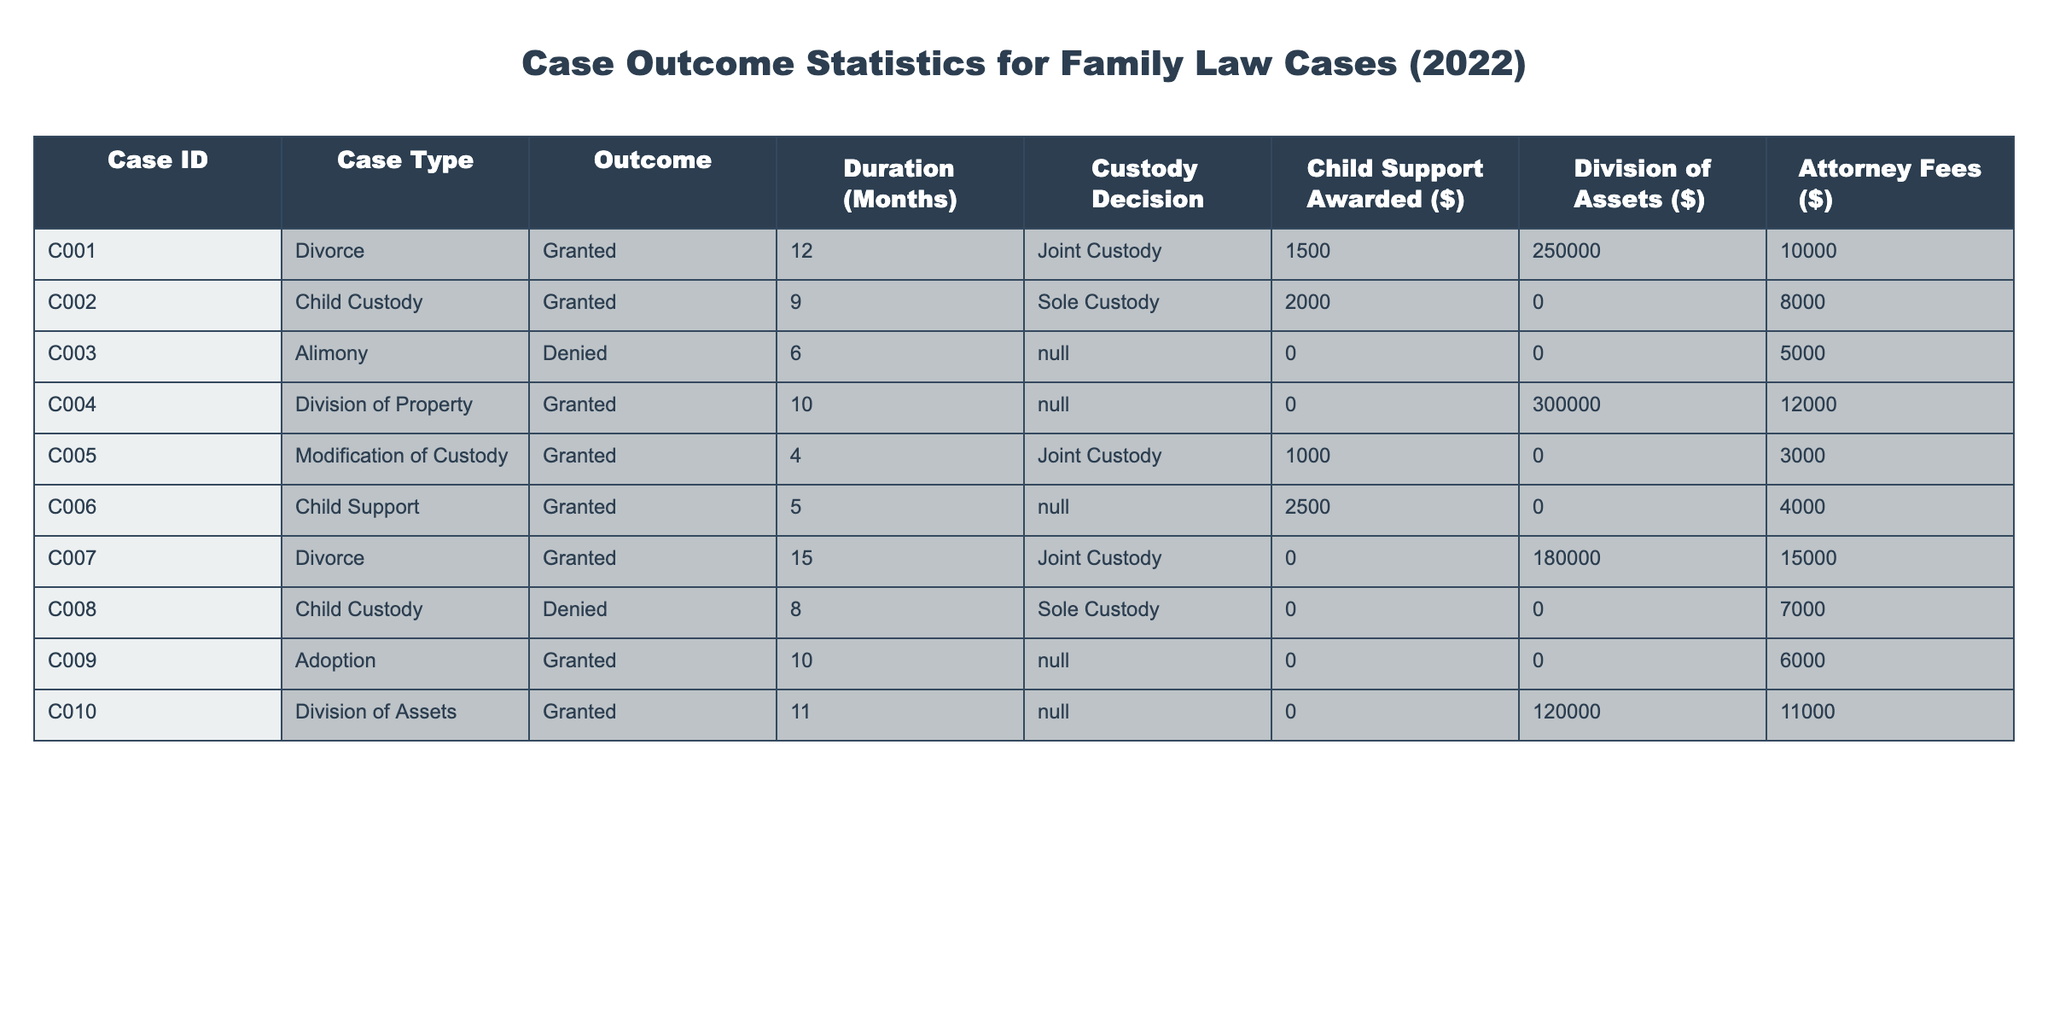What is the outcome of Case C002? According to the table, Case C002, which falls under the Child Custody category, has the outcome marked as "Granted".
Answer: Granted How many months did Case C007 take to resolve? The table indicates that the duration of Case C007 is 15 months.
Answer: 15 months Was the Child Support awarded in Case C006? The table shows that Case C006 has a Child Support Awarded value of $2500, indicating that it was indeed awarded.
Answer: Yes What is the total attorney fees for all cases where the outcome was "Granted"? To find the total attorney fees for granted outcomes, we sum the fees for the cases with "Granted": 10000 + 8000 + 12000 + 3000 + 4000 + 15000 + 11000 = 68000.
Answer: 68000 How many cases resulted in Joint Custody? In the table, we see that three cases (C001, C005, C007) resulted in Joint Custody.
Answer: 3 What was the average duration of cases that resulted in Denied outcomes? Only two cases resulted in "Denied": Case C003 and Case C008, with durations of 6 and 8 months respectively. Summing these, we have 6 + 8 = 14 months. There are 2 cases, so the average is 14 / 2 = 7 months.
Answer: 7 months Did any cases awarded Child Support have an attorney fee of over $10,000? Checking the relevant cases, Case C006 awarded $2500 Child Support with fees of $4000 and Case C002 did not award Child Support with fees of $8000, confirming that there were no cases satisfying both conditions.
Answer: No What is the total value of Child Support awarded across all cases? The table lists awards for cases as follows: $1500 (C001) + $2000 (C002) + $2500 (C006) = $6000. Adding these together gives a total Child Support of $6000.
Answer: 6000 